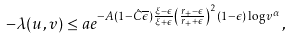Convert formula to latex. <formula><loc_0><loc_0><loc_500><loc_500>- \lambda ( u , v ) \leq a e ^ { - A ( 1 - \hat { C } \overline { \epsilon } ) \frac { \xi - \epsilon } { \xi + \epsilon } \left ( \frac { r _ { + } - \epsilon } { r _ { + } + \epsilon } \right ) ^ { 2 } ( 1 - \epsilon ) \log v ^ { \alpha } } ,</formula> 